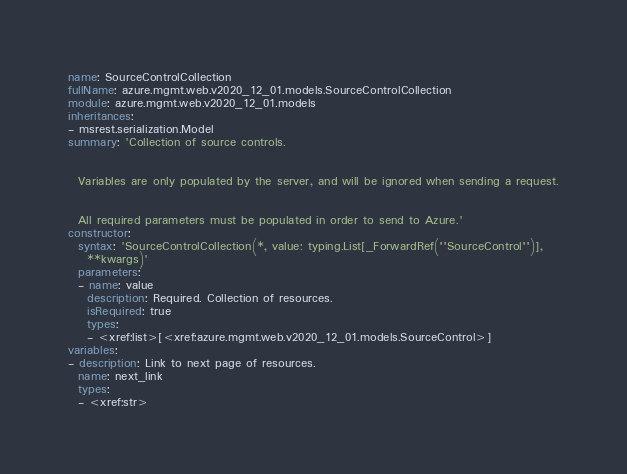<code> <loc_0><loc_0><loc_500><loc_500><_YAML_>name: SourceControlCollection
fullName: azure.mgmt.web.v2020_12_01.models.SourceControlCollection
module: azure.mgmt.web.v2020_12_01.models
inheritances:
- msrest.serialization.Model
summary: 'Collection of source controls.


  Variables are only populated by the server, and will be ignored when sending a request.


  All required parameters must be populated in order to send to Azure.'
constructor:
  syntax: 'SourceControlCollection(*, value: typing.List[_ForwardRef(''SourceControl'')],
    **kwargs)'
  parameters:
  - name: value
    description: Required. Collection of resources.
    isRequired: true
    types:
    - <xref:list>[<xref:azure.mgmt.web.v2020_12_01.models.SourceControl>]
variables:
- description: Link to next page of resources.
  name: next_link
  types:
  - <xref:str>
</code> 